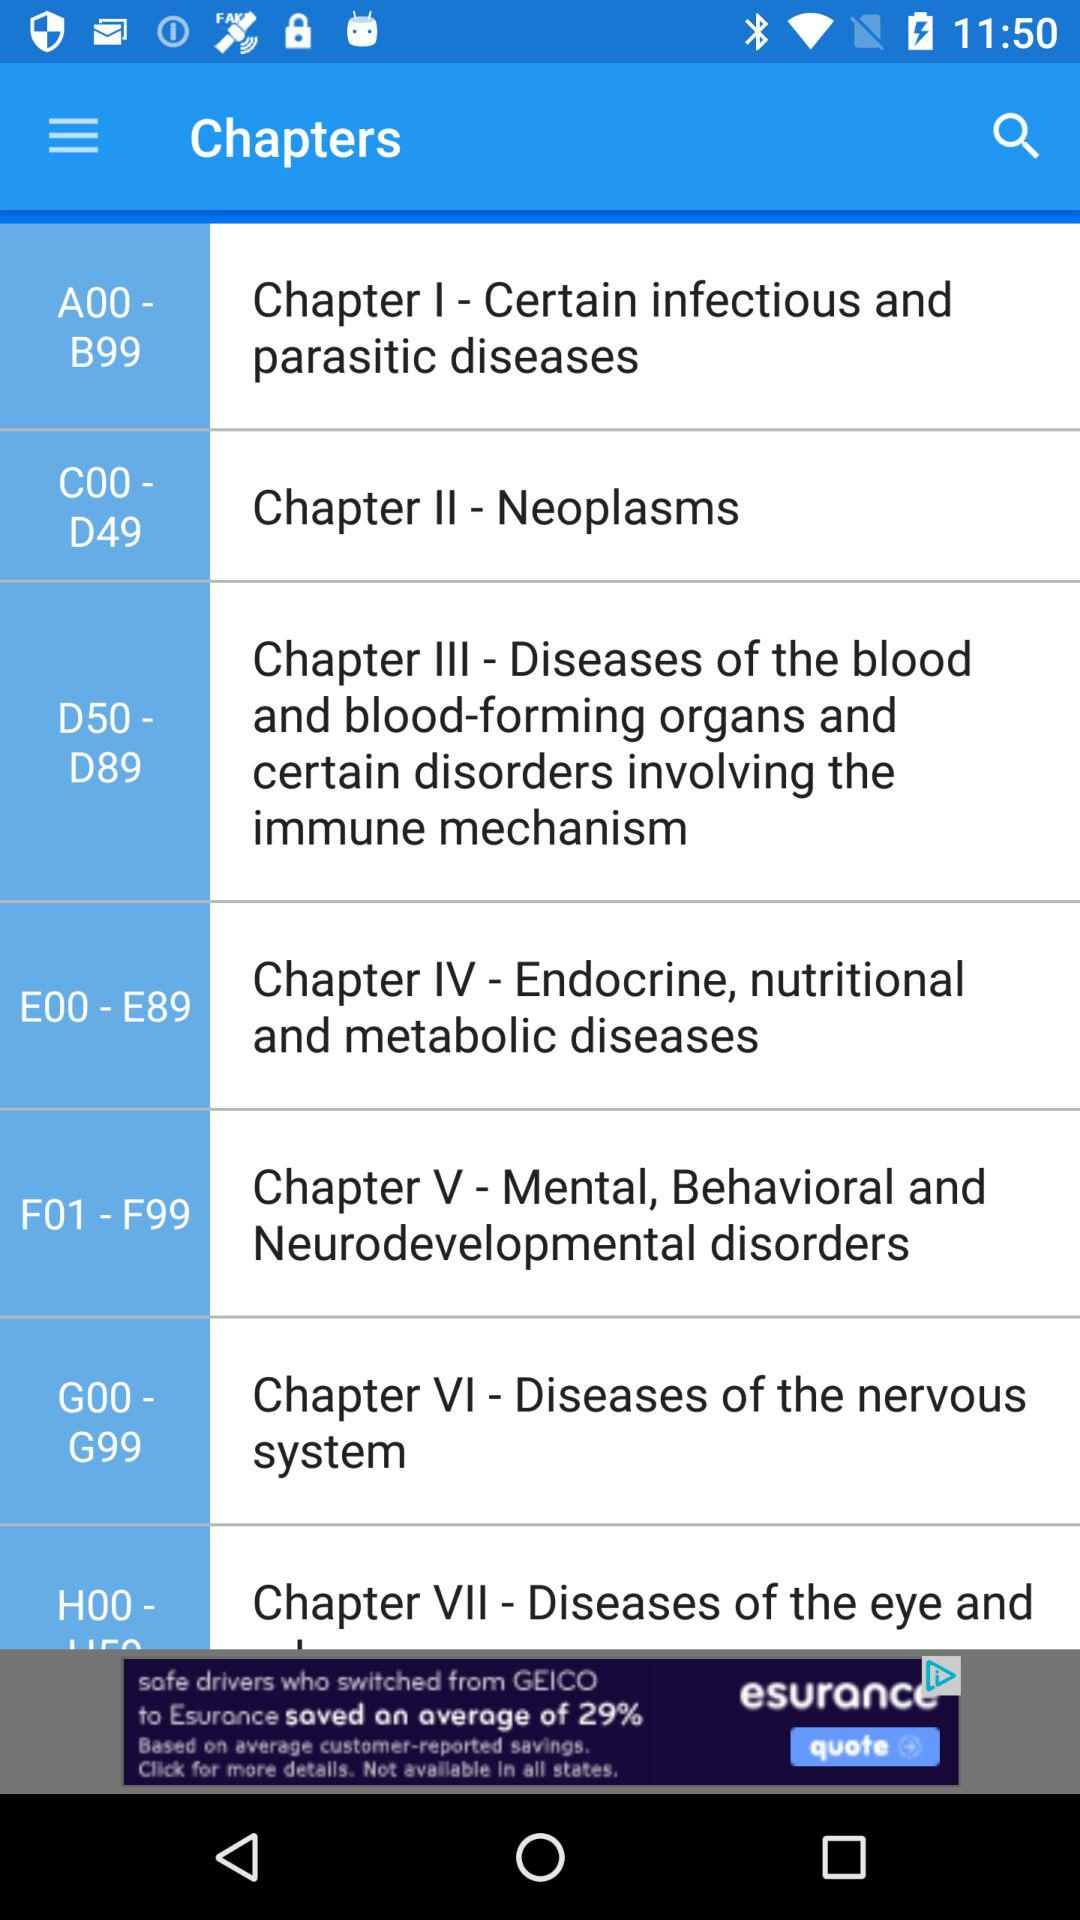How many chapters are there in total?
Answer the question using a single word or phrase. 7 